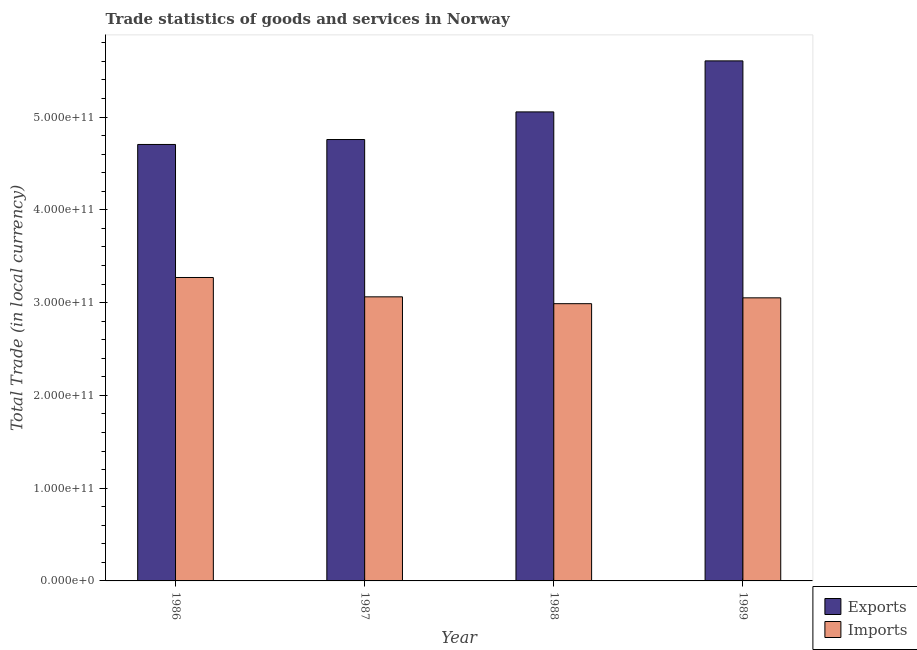Are the number of bars per tick equal to the number of legend labels?
Ensure brevity in your answer.  Yes. How many bars are there on the 2nd tick from the right?
Offer a very short reply. 2. What is the label of the 4th group of bars from the left?
Give a very brief answer. 1989. In how many cases, is the number of bars for a given year not equal to the number of legend labels?
Make the answer very short. 0. What is the export of goods and services in 1987?
Provide a succinct answer. 4.76e+11. Across all years, what is the maximum imports of goods and services?
Give a very brief answer. 3.27e+11. Across all years, what is the minimum export of goods and services?
Offer a very short reply. 4.70e+11. In which year was the imports of goods and services maximum?
Give a very brief answer. 1986. What is the total export of goods and services in the graph?
Make the answer very short. 2.01e+12. What is the difference between the export of goods and services in 1986 and that in 1989?
Your response must be concise. -9.01e+1. What is the difference between the export of goods and services in 1988 and the imports of goods and services in 1986?
Give a very brief answer. 3.51e+1. What is the average export of goods and services per year?
Your response must be concise. 5.03e+11. What is the ratio of the imports of goods and services in 1987 to that in 1989?
Ensure brevity in your answer.  1. What is the difference between the highest and the second highest imports of goods and services?
Provide a short and direct response. 2.09e+1. What is the difference between the highest and the lowest export of goods and services?
Offer a terse response. 9.01e+1. Is the sum of the export of goods and services in 1987 and 1989 greater than the maximum imports of goods and services across all years?
Offer a very short reply. Yes. What does the 1st bar from the left in 1987 represents?
Provide a succinct answer. Exports. What does the 2nd bar from the right in 1987 represents?
Offer a very short reply. Exports. What is the difference between two consecutive major ticks on the Y-axis?
Give a very brief answer. 1.00e+11. Does the graph contain any zero values?
Offer a terse response. No. Where does the legend appear in the graph?
Your answer should be compact. Bottom right. How many legend labels are there?
Your answer should be very brief. 2. How are the legend labels stacked?
Ensure brevity in your answer.  Vertical. What is the title of the graph?
Your response must be concise. Trade statistics of goods and services in Norway. What is the label or title of the X-axis?
Make the answer very short. Year. What is the label or title of the Y-axis?
Keep it short and to the point. Total Trade (in local currency). What is the Total Trade (in local currency) of Exports in 1986?
Your answer should be very brief. 4.70e+11. What is the Total Trade (in local currency) in Imports in 1986?
Your answer should be compact. 3.27e+11. What is the Total Trade (in local currency) of Exports in 1987?
Provide a short and direct response. 4.76e+11. What is the Total Trade (in local currency) in Imports in 1987?
Give a very brief answer. 3.06e+11. What is the Total Trade (in local currency) in Exports in 1988?
Give a very brief answer. 5.06e+11. What is the Total Trade (in local currency) in Imports in 1988?
Your answer should be compact. 2.99e+11. What is the Total Trade (in local currency) in Exports in 1989?
Give a very brief answer. 5.61e+11. What is the Total Trade (in local currency) in Imports in 1989?
Make the answer very short. 3.05e+11. Across all years, what is the maximum Total Trade (in local currency) in Exports?
Your answer should be compact. 5.61e+11. Across all years, what is the maximum Total Trade (in local currency) in Imports?
Your answer should be very brief. 3.27e+11. Across all years, what is the minimum Total Trade (in local currency) of Exports?
Offer a very short reply. 4.70e+11. Across all years, what is the minimum Total Trade (in local currency) of Imports?
Make the answer very short. 2.99e+11. What is the total Total Trade (in local currency) of Exports in the graph?
Keep it short and to the point. 2.01e+12. What is the total Total Trade (in local currency) of Imports in the graph?
Provide a succinct answer. 1.24e+12. What is the difference between the Total Trade (in local currency) in Exports in 1986 and that in 1987?
Offer a terse response. -5.33e+09. What is the difference between the Total Trade (in local currency) in Imports in 1986 and that in 1987?
Provide a short and direct response. 2.09e+1. What is the difference between the Total Trade (in local currency) of Exports in 1986 and that in 1988?
Give a very brief answer. -3.51e+1. What is the difference between the Total Trade (in local currency) of Imports in 1986 and that in 1988?
Offer a very short reply. 2.82e+1. What is the difference between the Total Trade (in local currency) of Exports in 1986 and that in 1989?
Offer a terse response. -9.01e+1. What is the difference between the Total Trade (in local currency) of Imports in 1986 and that in 1989?
Offer a very short reply. 2.19e+1. What is the difference between the Total Trade (in local currency) of Exports in 1987 and that in 1988?
Keep it short and to the point. -2.98e+1. What is the difference between the Total Trade (in local currency) of Imports in 1987 and that in 1988?
Ensure brevity in your answer.  7.38e+09. What is the difference between the Total Trade (in local currency) in Exports in 1987 and that in 1989?
Give a very brief answer. -8.48e+1. What is the difference between the Total Trade (in local currency) in Imports in 1987 and that in 1989?
Provide a short and direct response. 1.08e+09. What is the difference between the Total Trade (in local currency) in Exports in 1988 and that in 1989?
Offer a terse response. -5.50e+1. What is the difference between the Total Trade (in local currency) of Imports in 1988 and that in 1989?
Your answer should be very brief. -6.30e+09. What is the difference between the Total Trade (in local currency) of Exports in 1986 and the Total Trade (in local currency) of Imports in 1987?
Your answer should be very brief. 1.64e+11. What is the difference between the Total Trade (in local currency) in Exports in 1986 and the Total Trade (in local currency) in Imports in 1988?
Your answer should be very brief. 1.72e+11. What is the difference between the Total Trade (in local currency) in Exports in 1986 and the Total Trade (in local currency) in Imports in 1989?
Provide a succinct answer. 1.65e+11. What is the difference between the Total Trade (in local currency) of Exports in 1987 and the Total Trade (in local currency) of Imports in 1988?
Give a very brief answer. 1.77e+11. What is the difference between the Total Trade (in local currency) of Exports in 1987 and the Total Trade (in local currency) of Imports in 1989?
Provide a short and direct response. 1.71e+11. What is the difference between the Total Trade (in local currency) in Exports in 1988 and the Total Trade (in local currency) in Imports in 1989?
Offer a terse response. 2.00e+11. What is the average Total Trade (in local currency) in Exports per year?
Offer a terse response. 5.03e+11. What is the average Total Trade (in local currency) in Imports per year?
Your answer should be compact. 3.09e+11. In the year 1986, what is the difference between the Total Trade (in local currency) in Exports and Total Trade (in local currency) in Imports?
Your response must be concise. 1.43e+11. In the year 1987, what is the difference between the Total Trade (in local currency) in Exports and Total Trade (in local currency) in Imports?
Your answer should be very brief. 1.70e+11. In the year 1988, what is the difference between the Total Trade (in local currency) of Exports and Total Trade (in local currency) of Imports?
Make the answer very short. 2.07e+11. In the year 1989, what is the difference between the Total Trade (in local currency) of Exports and Total Trade (in local currency) of Imports?
Your answer should be very brief. 2.55e+11. What is the ratio of the Total Trade (in local currency) in Imports in 1986 to that in 1987?
Make the answer very short. 1.07. What is the ratio of the Total Trade (in local currency) in Exports in 1986 to that in 1988?
Offer a terse response. 0.93. What is the ratio of the Total Trade (in local currency) in Imports in 1986 to that in 1988?
Ensure brevity in your answer.  1.09. What is the ratio of the Total Trade (in local currency) of Exports in 1986 to that in 1989?
Provide a succinct answer. 0.84. What is the ratio of the Total Trade (in local currency) of Imports in 1986 to that in 1989?
Offer a very short reply. 1.07. What is the ratio of the Total Trade (in local currency) in Exports in 1987 to that in 1988?
Provide a short and direct response. 0.94. What is the ratio of the Total Trade (in local currency) in Imports in 1987 to that in 1988?
Your answer should be very brief. 1.02. What is the ratio of the Total Trade (in local currency) in Exports in 1987 to that in 1989?
Offer a terse response. 0.85. What is the ratio of the Total Trade (in local currency) in Imports in 1987 to that in 1989?
Provide a succinct answer. 1. What is the ratio of the Total Trade (in local currency) of Exports in 1988 to that in 1989?
Offer a terse response. 0.9. What is the ratio of the Total Trade (in local currency) in Imports in 1988 to that in 1989?
Provide a short and direct response. 0.98. What is the difference between the highest and the second highest Total Trade (in local currency) in Exports?
Your response must be concise. 5.50e+1. What is the difference between the highest and the second highest Total Trade (in local currency) in Imports?
Your answer should be compact. 2.09e+1. What is the difference between the highest and the lowest Total Trade (in local currency) in Exports?
Provide a succinct answer. 9.01e+1. What is the difference between the highest and the lowest Total Trade (in local currency) in Imports?
Your answer should be compact. 2.82e+1. 